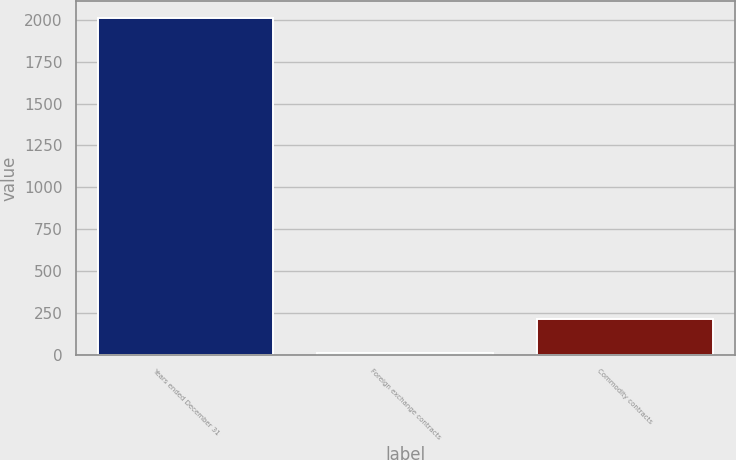<chart> <loc_0><loc_0><loc_500><loc_500><bar_chart><fcel>Years ended December 31<fcel>Foreign exchange contracts<fcel>Commodity contracts<nl><fcel>2011<fcel>12<fcel>211.9<nl></chart> 